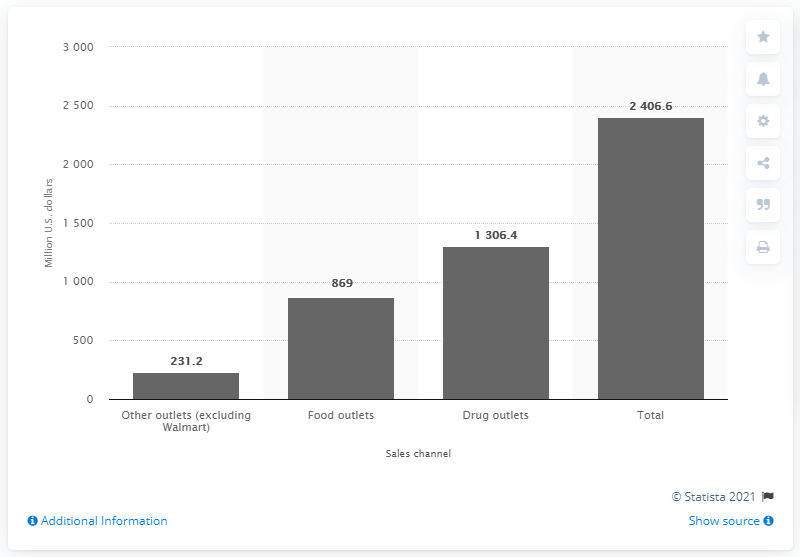Draw attention to some important aspects in this diagram. In 2011/2012, a total of 869 dollars were spent on internal analgesics via food outlets. In 2011 and 2012, the total amount of internal analgesic sales in the United States was approximately 2,406.6 million units. 